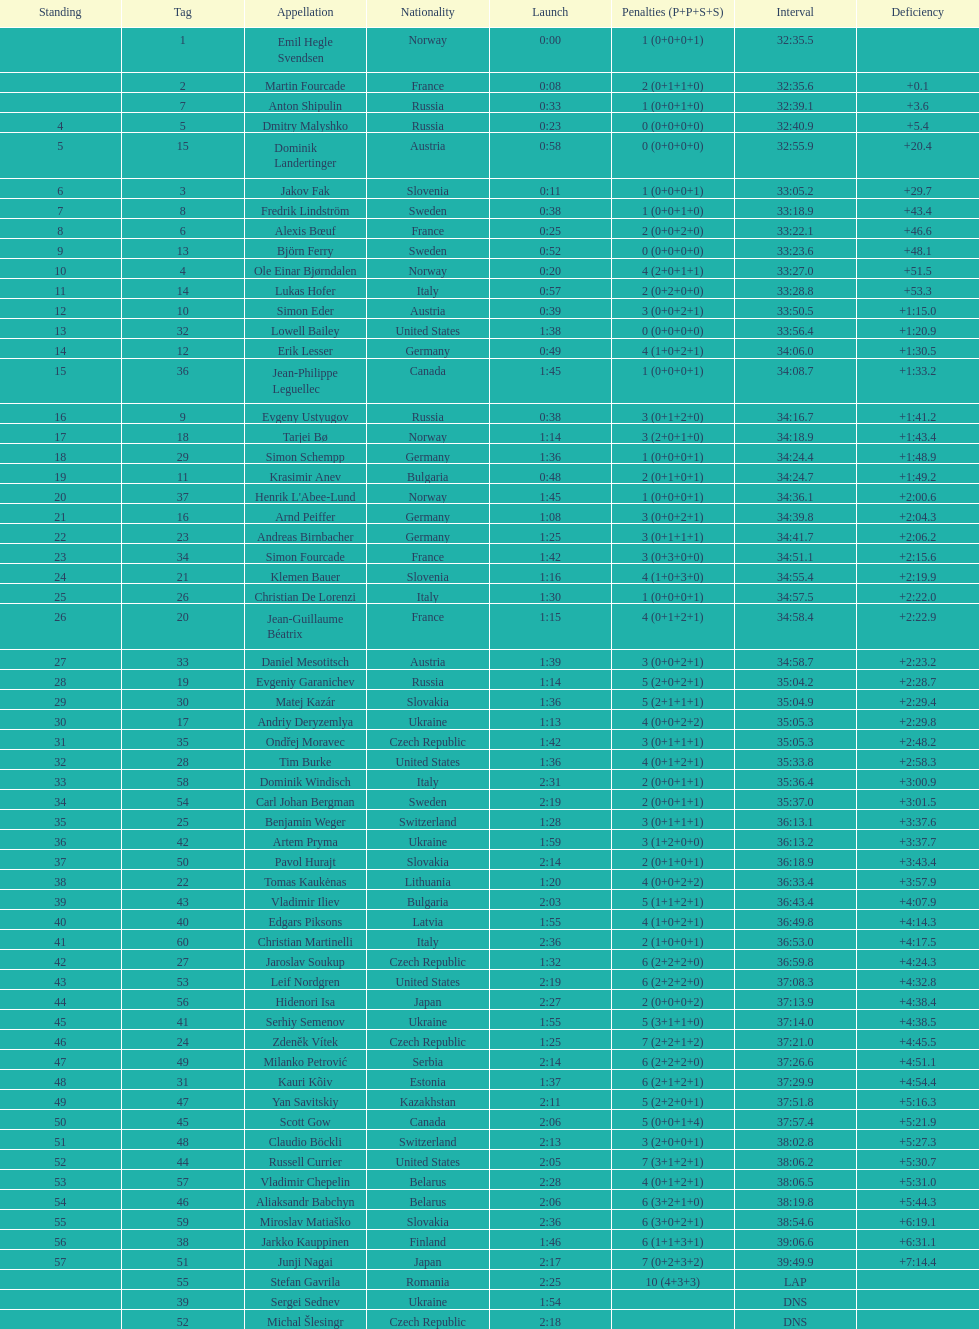Other than burke, name an athlete from the us. Leif Nordgren. 